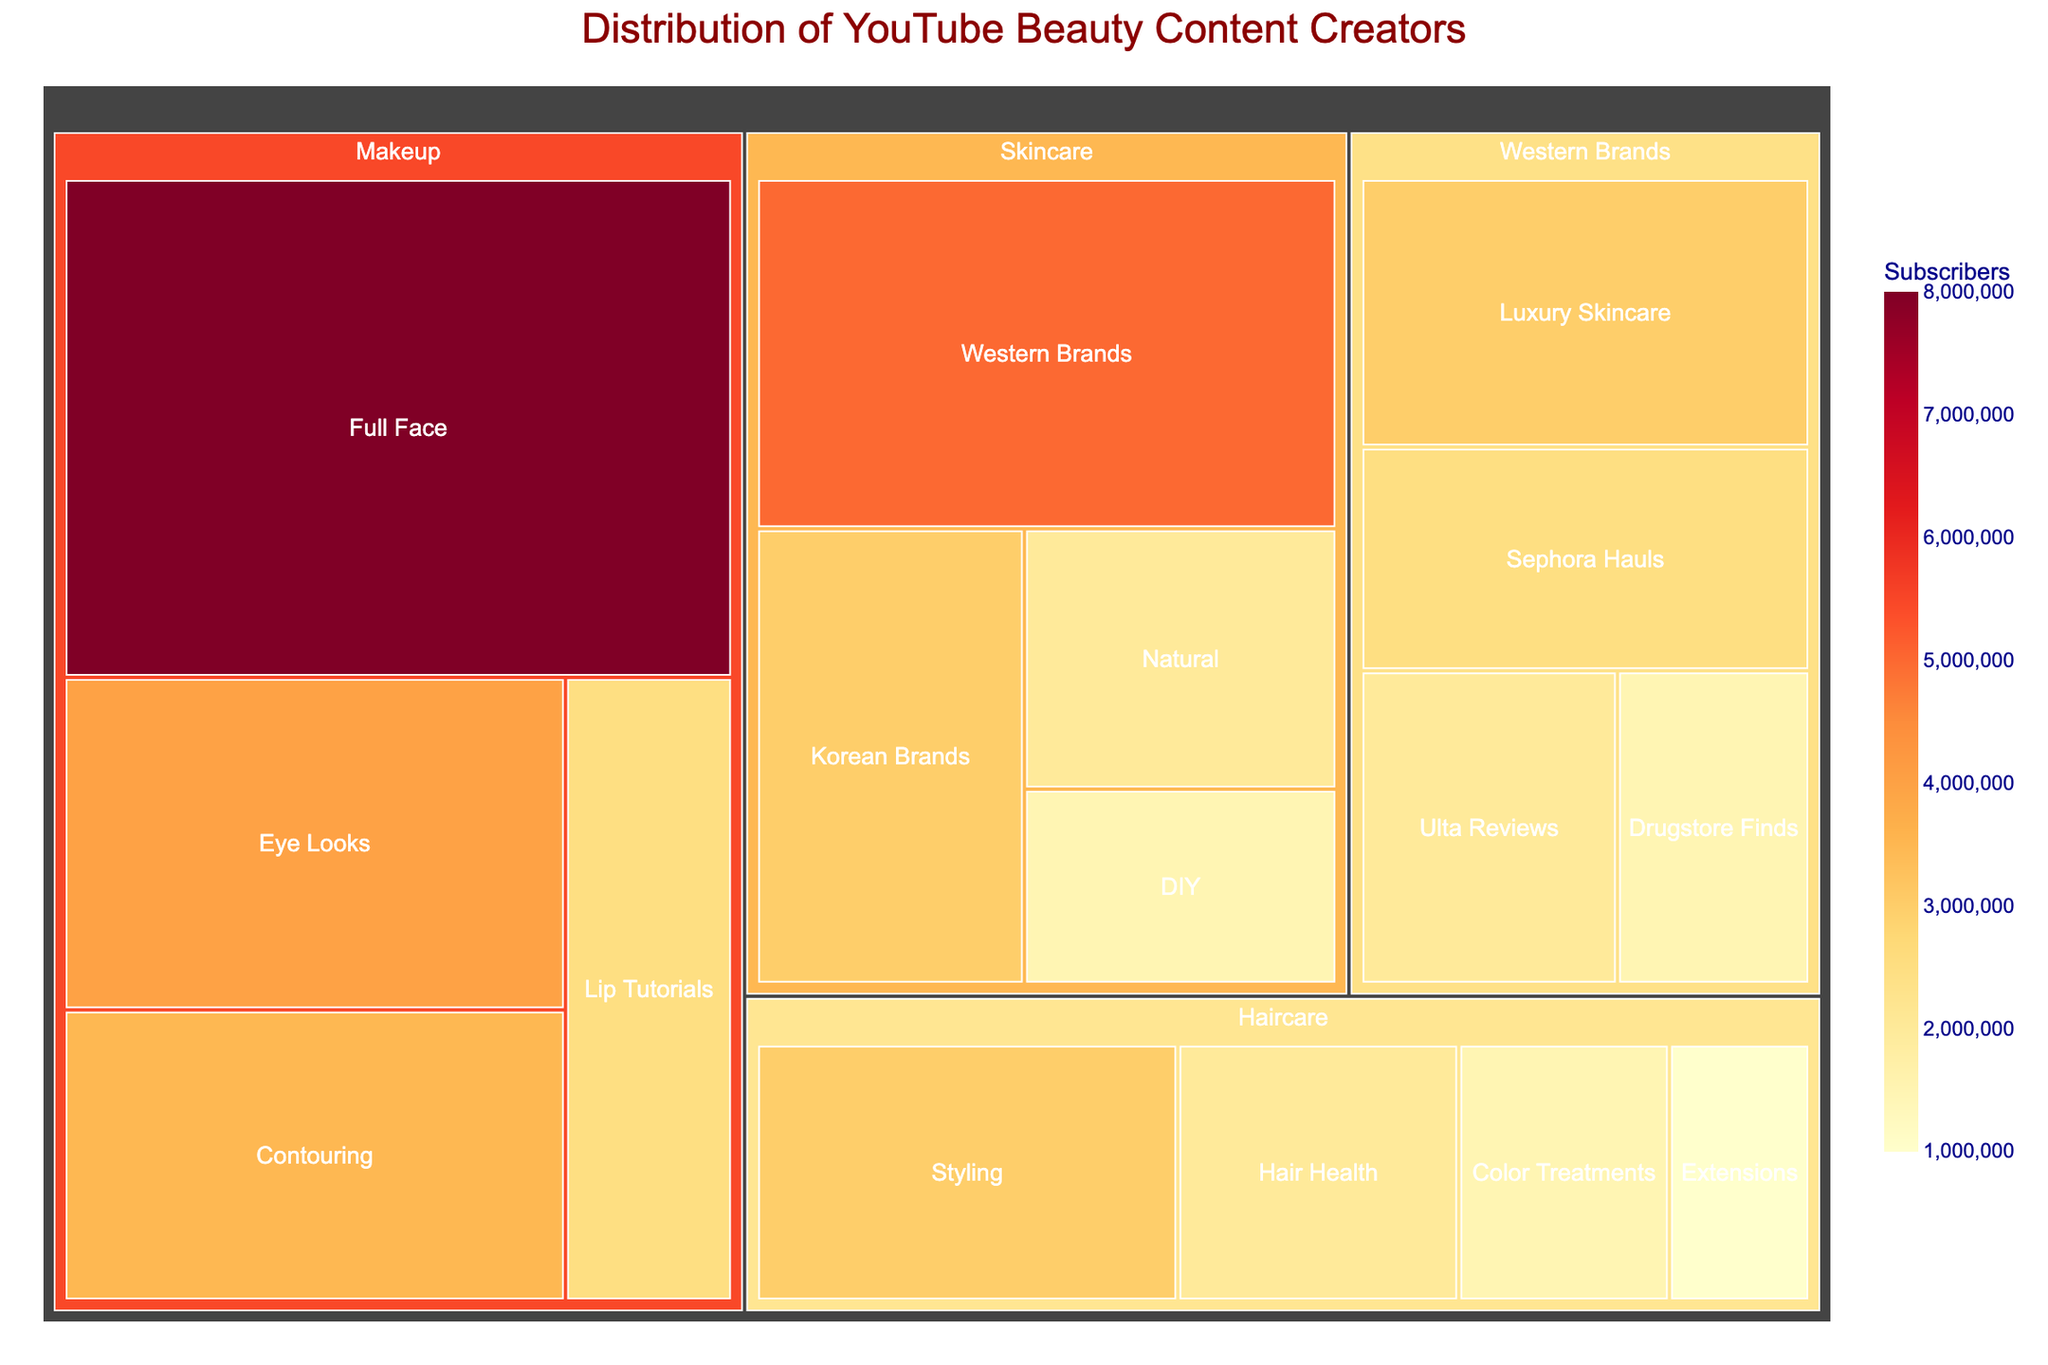What's the highest subscriber count subcategory under Makeup? Scan under the Makeup category in the treemap and identify which subcategory has the largest area, which corresponds to the highest subscriber count. The largest area in Makeup corresponds to "Full Face".
Answer: Full Face What's the total number of subscribers for the Skincare category? Sum the subscriber counts for all subcategories under Skincare: Western Brands (5,000,000), Korean Brands (3,000,000), DIY (1,500,000), and Natural (2,000,000). Adding these, we get 11,500,000.
Answer: 11,500,000 Which category has the smallest number of subscribers? Compare the total areas for each category: Skincare, Makeup, Haircare. The smallest area corresponds to Haircare.
Answer: Haircare How do Western Brands in Skincare compare to Luxury Skincare in terms of subscribers? Western Brands have 5,000,000 subscribers in the Skincare category. Under Western Brands, Luxury Skincare (Luxury Skincare) has 3,000,000 subscribers. Western Brands has more subscribers.
Answer: Western Brands What subcategory within Haircare has the least number of subscribers? Check the subcategories under Haircare and find the one with the smallest area: Extensions (1,000,000).
Answer: Extensions How many categories are represented in the treemap? Count the number of unique top-level categories: Skincare, Makeup, Haircare.
Answer: 3 Which subcategory under Makeup has more subscribers, Eye Looks or Lip Tutorials? Compare the areas of Eye Looks (4,000,000) and Lip Tutorials (2,500,000). Eye Looks has more subscribers.
Answer: Eye Looks What is the approximate difference in subscribers between Full Face makeup and Styling haircare? Full Face has 8,000,000 subscribers, and Styling has 3,000,000 subscribers. The difference is 8,000,000 - 3,000,000 = 5,000,000.
Answer: 5,000,000 What's the primary focus category with the highest number of total subscribers? Sum total subscribers in each main category: Skincare (11,500,000), Makeup (18,500,000), Haircare (7,000,000). Makeup has the highest with 18,500,000.
Answer: Makeup Is there more interest in Drugstore Finds under Western Brands or in Natural Skincare? Compare Drugstore Finds (1,500,000) under Western Brands with Natural Skincare (2,000,000). Natural Skincare has more subscribers.
Answer: Natural Skincare 